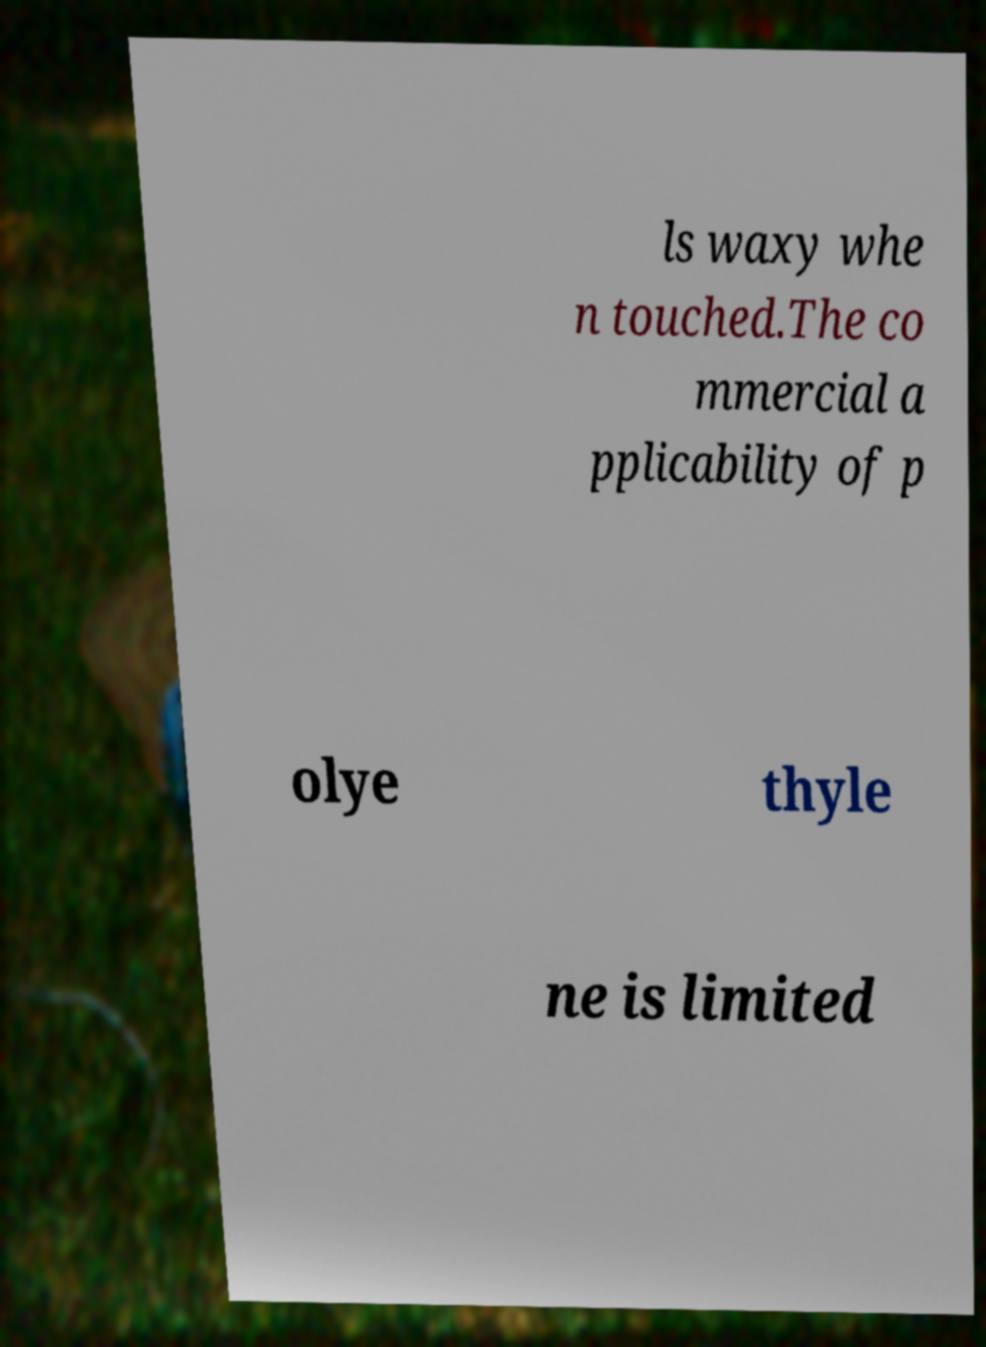Can you accurately transcribe the text from the provided image for me? ls waxy whe n touched.The co mmercial a pplicability of p olye thyle ne is limited 